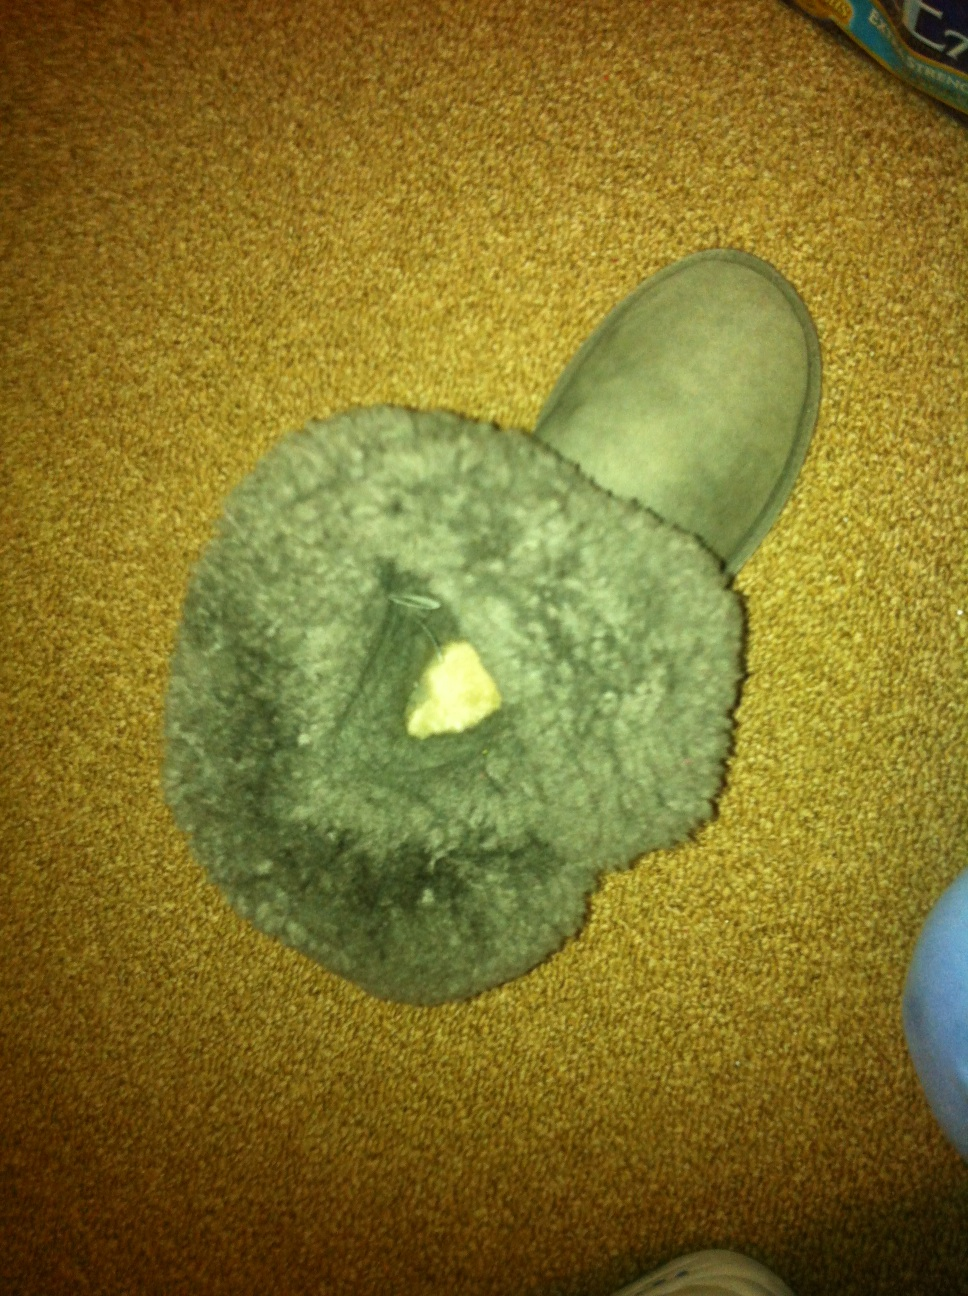Let's go wild with our imagination! What magical properties could this boot have in a fantasy world? In a fantastical world, this boot could possess several magical properties. Perhaps it has the ability to allow the wearer to traverse vast distances in mere moments, effectively teleporting them to their desired destination. Additionally, the fur lining could provide not just warmth but also amplify the wearer’s resilience against the elements, making them impervious to extreme cold and even helping to heal injuries. The boot’s sole might leave behind a trail of protective enchantment, neutralizing any traps or spells lying in wait. Moreover, the wearer could communicate with animals, with the boot translating animal sounds into understandable language, forging a deep connection with nature. In epic tales, such a boot could be the key to unlocking ancient secrets, guiding the hero to lost treasures and forgotten lands, each step resonating with mystical energy. 